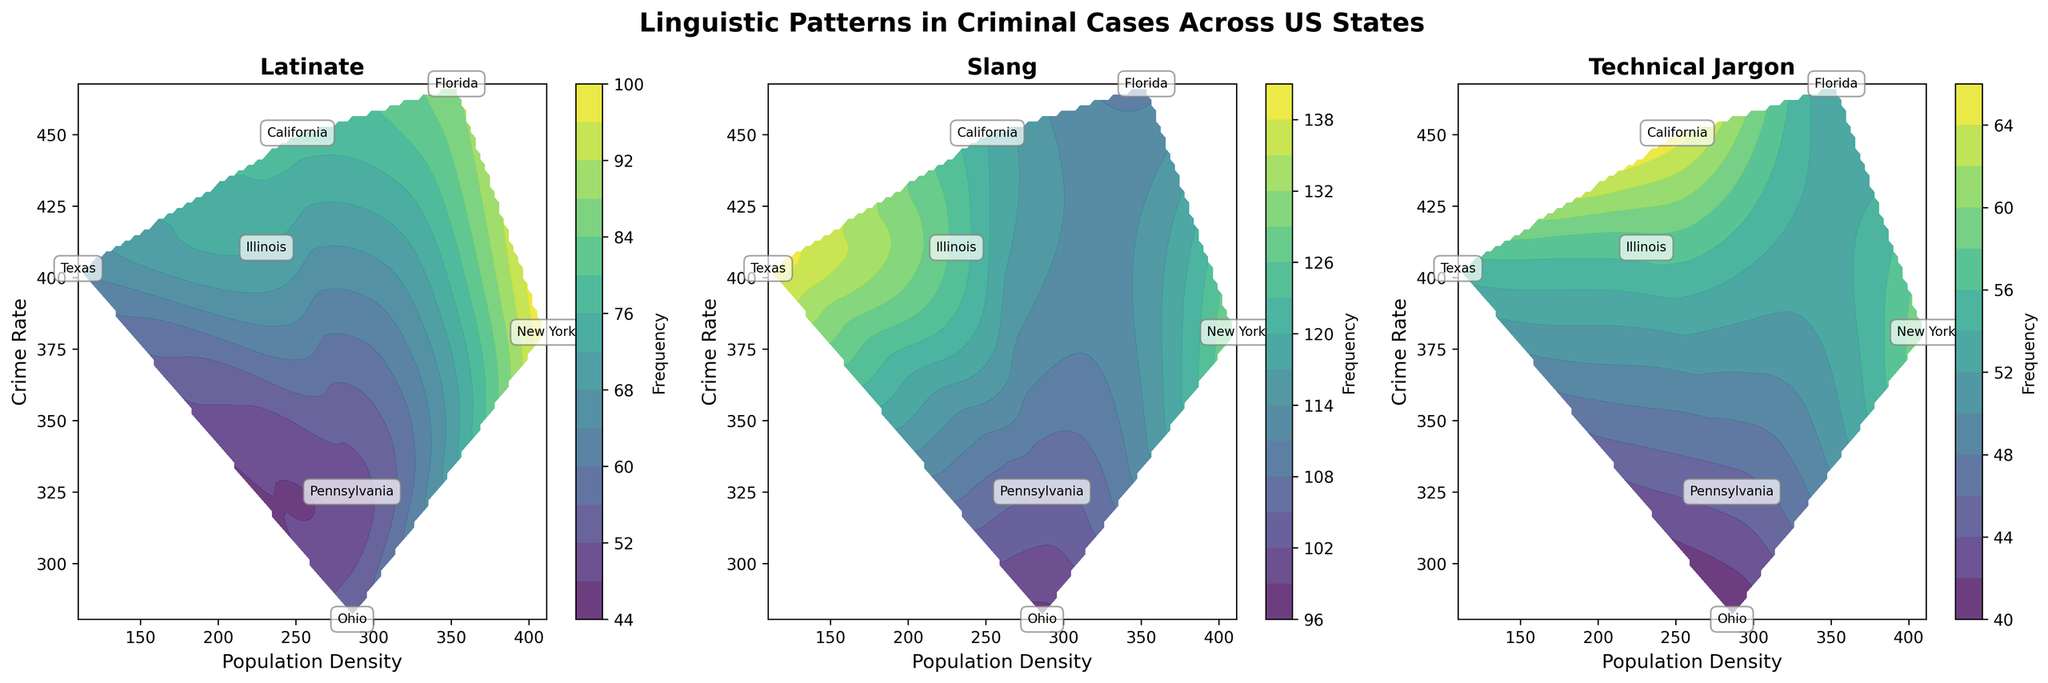What's the title of the figure? The title is usually placed at the top of the figure. It summarizes the main topic or focus of the plot in a concise manner. In this case, it would summarize the linguistic patterns in criminal cases across different US states.
Answer: Linguistic Patterns in Criminal Cases Across US States Which linguistic pattern has the highest frequency in California? Identify the subplot labeled "California," then check the frequency values for each linguistic pattern. Compare them to find the highest one. In the "California" subplot, the frequencies are 78 for Latinate, 120 for Slang, and 65 for Technical Jargon.
Answer: Slang Describe the general trend of crime rate and population density for the Slang pattern. Look at the "Slang" subplot and notice the distribution of crime rates and population densities. Patterns or groupings of data points will give insights. For "Slang," the data points are generally higher in crime rate and have a wide range of population densities.
Answer: Higher crime rate, wide population density range In which state does the Technical Jargon occur most frequently? Find the subplot labeled "Technical Jargon" and identify the state that has the highest frequency marker or contour level. In the "Technical Jargon" subplot, one has to look at the highest peak area.
Answer: California Which state has the lowest crime rate for the Latinate pattern? Check the subplot labeled "Latinate" and locate the state with the lowest crime rate value. Compare the crime rates for each state annotation. Ohio has the lowest crime rate label of 280.5.
Answer: Ohio What is the range of population densities across all states for the Slang pattern? Examine the "Slang" subplot, noting the range of population density values across different annotations/contour levels. The population densities range between 100 to 400 in the density axis.
Answer: 100 to 400 How do the frequency levels of the Latinate pattern in Texas compare to those in Florida? Compare frequency values or contour levels between Texas and Florida within the "Latinate" subplot. Texas has a frequency of 65, while Florida has a frequency of 88.
Answer: Lower in Texas than Florida Which common linguistic pattern shows the highest variance in frequencies across states? Compare the spread of frequency values in each subplot (Latinate, Slang, Technical Jargon). Identify the language pattern with the most variation in numerical values or contour levels. The Slang pattern shows the highest variability in values.
Answer: Slang Is there a correlation between population density and crime rate for the Technical Jargon pattern? Examine the "Technical Jargon" subplot to see if higher population densities generally correspond with higher crime rates or vice versa. Detect trends or overall movement in data clusters. There's no clear correlation seen between population density and crime rate for Technical Jargon.
Answer: No clear correlation Which linguistic pattern is more frequent in states with higher population densities? Look at each subplot and trace the contours for higher population densities. Compare frequency peaks for Latinate, Slang, and Technical Jargon in higher density regions around 300-400. Patterns should indicate that the Slang pattern is more frequent.
Answer: Slang 